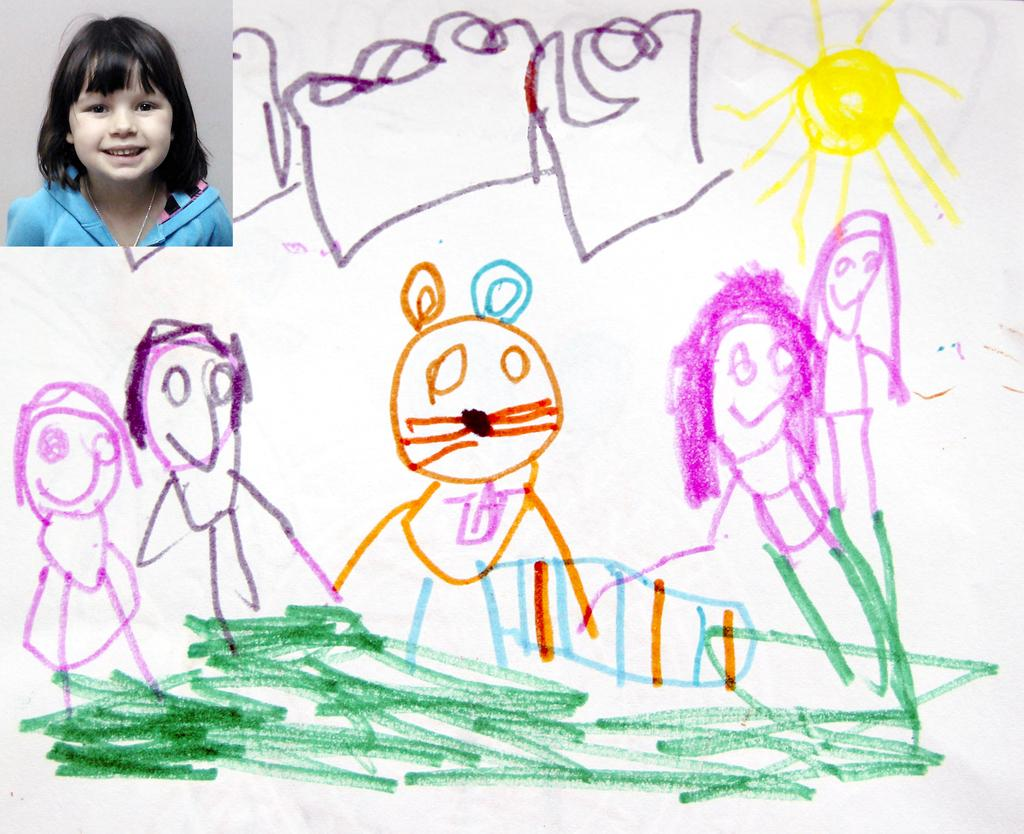What is present on the paper in the image? There is a picture of a kid at the left top of the paper and a drawing on the paper. Can you describe the picture of the kid on the paper? The picture of the kid is located at the left top of the paper. What else can be seen on the paper besides the picture of the kid? There is a drawing on the paper. What type of lettuce is being used as a prop in the picture of the kid? There is no lettuce present in the image; it features a picture of a kid and a drawing on a paper. Who is the manager of the drawing on the paper? There is no manager mentioned or implied in the image; it only shows a paper with a picture of a kid and a drawing. 